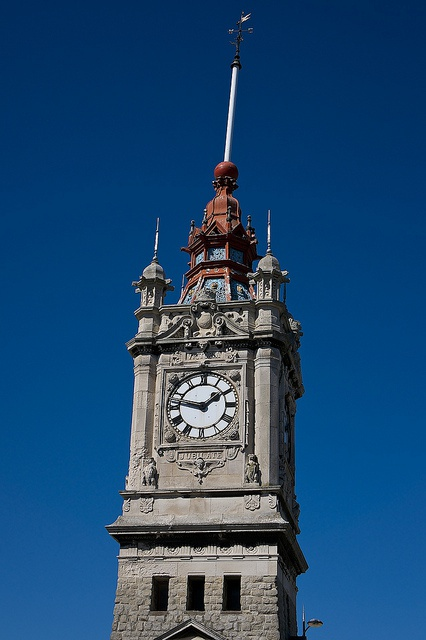Describe the objects in this image and their specific colors. I can see clock in navy, lightgray, black, gray, and darkgray tones and clock in navy, black, and blue tones in this image. 